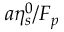Convert formula to latex. <formula><loc_0><loc_0><loc_500><loc_500>a \eta _ { s } ^ { 0 } / F _ { p }</formula> 